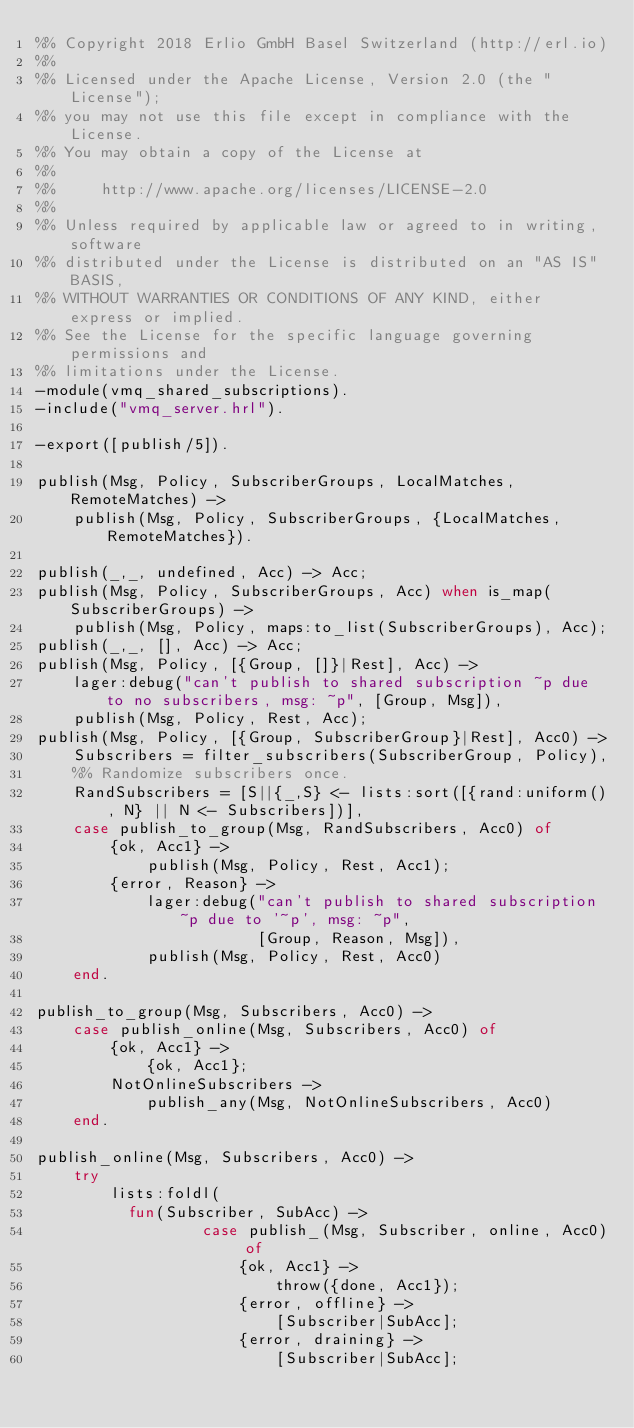<code> <loc_0><loc_0><loc_500><loc_500><_Erlang_>%% Copyright 2018 Erlio GmbH Basel Switzerland (http://erl.io)
%%
%% Licensed under the Apache License, Version 2.0 (the "License");
%% you may not use this file except in compliance with the License.
%% You may obtain a copy of the License at
%%
%%     http://www.apache.org/licenses/LICENSE-2.0
%%
%% Unless required by applicable law or agreed to in writing, software
%% distributed under the License is distributed on an "AS IS" BASIS,
%% WITHOUT WARRANTIES OR CONDITIONS OF ANY KIND, either express or implied.
%% See the License for the specific language governing permissions and
%% limitations under the License.
-module(vmq_shared_subscriptions).
-include("vmq_server.hrl").

-export([publish/5]).

publish(Msg, Policy, SubscriberGroups, LocalMatches, RemoteMatches) ->
    publish(Msg, Policy, SubscriberGroups, {LocalMatches, RemoteMatches}).

publish(_,_, undefined, Acc) -> Acc;
publish(Msg, Policy, SubscriberGroups, Acc) when is_map(SubscriberGroups) ->
    publish(Msg, Policy, maps:to_list(SubscriberGroups), Acc);
publish(_,_, [], Acc) -> Acc;
publish(Msg, Policy, [{Group, []}|Rest], Acc) ->
    lager:debug("can't publish to shared subscription ~p due to no subscribers, msg: ~p", [Group, Msg]),
    publish(Msg, Policy, Rest, Acc);
publish(Msg, Policy, [{Group, SubscriberGroup}|Rest], Acc0) ->
    Subscribers = filter_subscribers(SubscriberGroup, Policy),
    %% Randomize subscribers once.
    RandSubscribers = [S||{_,S} <- lists:sort([{rand:uniform(), N} || N <- Subscribers])],
    case publish_to_group(Msg, RandSubscribers, Acc0) of
        {ok, Acc1} ->
            publish(Msg, Policy, Rest, Acc1);
        {error, Reason} ->
            lager:debug("can't publish to shared subscription ~p due to '~p', msg: ~p",
                        [Group, Reason, Msg]),
            publish(Msg, Policy, Rest, Acc0)
    end.

publish_to_group(Msg, Subscribers, Acc0) ->
    case publish_online(Msg, Subscribers, Acc0) of
        {ok, Acc1} ->
            {ok, Acc1};
        NotOnlineSubscribers ->
            publish_any(Msg, NotOnlineSubscribers, Acc0)
    end.

publish_online(Msg, Subscribers, Acc0) ->
    try
        lists:foldl(
          fun(Subscriber, SubAcc) ->
                  case publish_(Msg, Subscriber, online, Acc0) of
                      {ok, Acc1} ->
                          throw({done, Acc1});
                      {error, offline} ->
                          [Subscriber|SubAcc];
                      {error, draining} ->
                          [Subscriber|SubAcc];</code> 